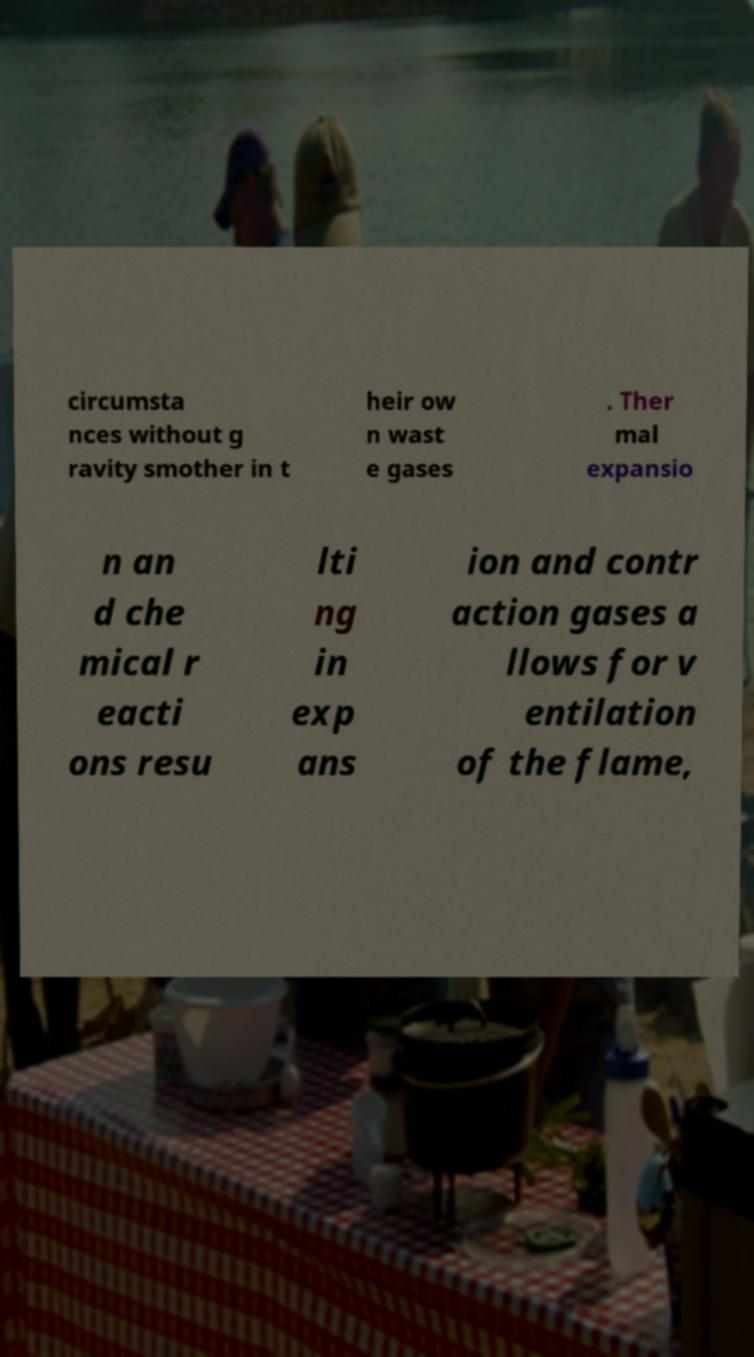There's text embedded in this image that I need extracted. Can you transcribe it verbatim? circumsta nces without g ravity smother in t heir ow n wast e gases . Ther mal expansio n an d che mical r eacti ons resu lti ng in exp ans ion and contr action gases a llows for v entilation of the flame, 